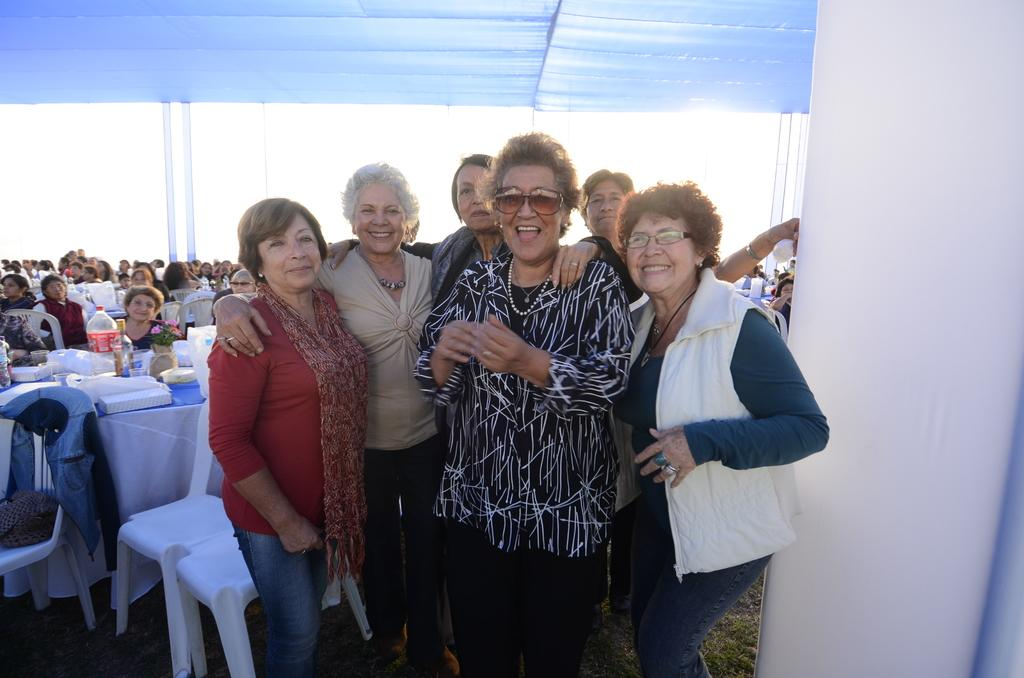What is the general activity of the people in the image? There is a group of people standing and another group sitting on chairs in the image. What is the facial expression of the people in the image? The people in the image are smiling. What can be seen on the tables in the image? There are objects on the tables in the image. What type of throne can be seen in the image? There is no throne present in the image. Can you tell me the total cost of the items on the receipt in the image? There is no receipt present in the image. 